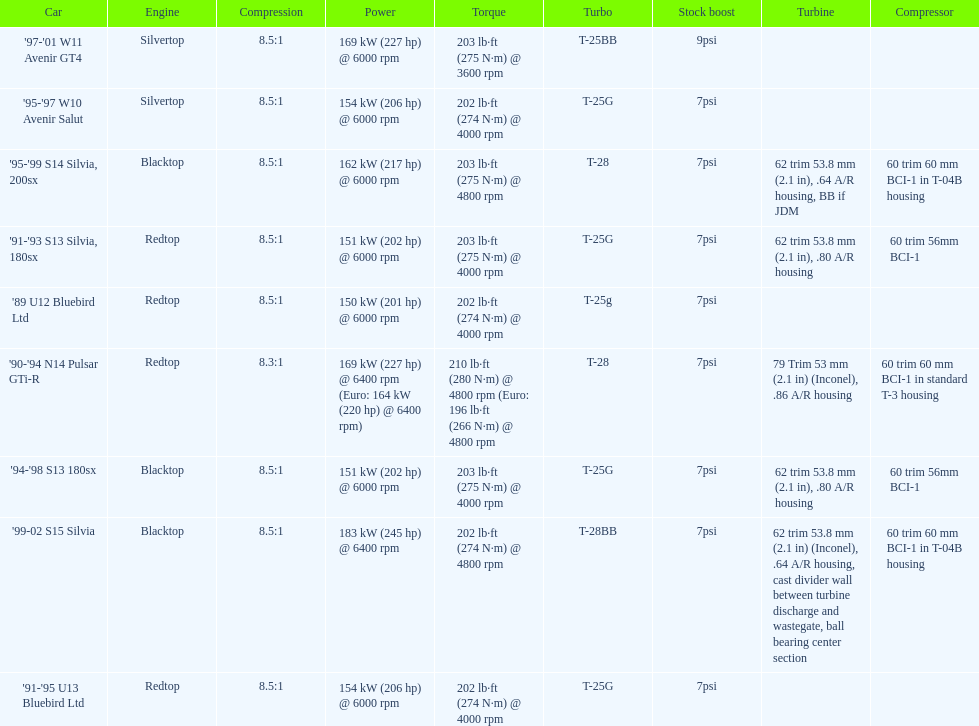Which engine(s) has the least amount of power? Redtop. 